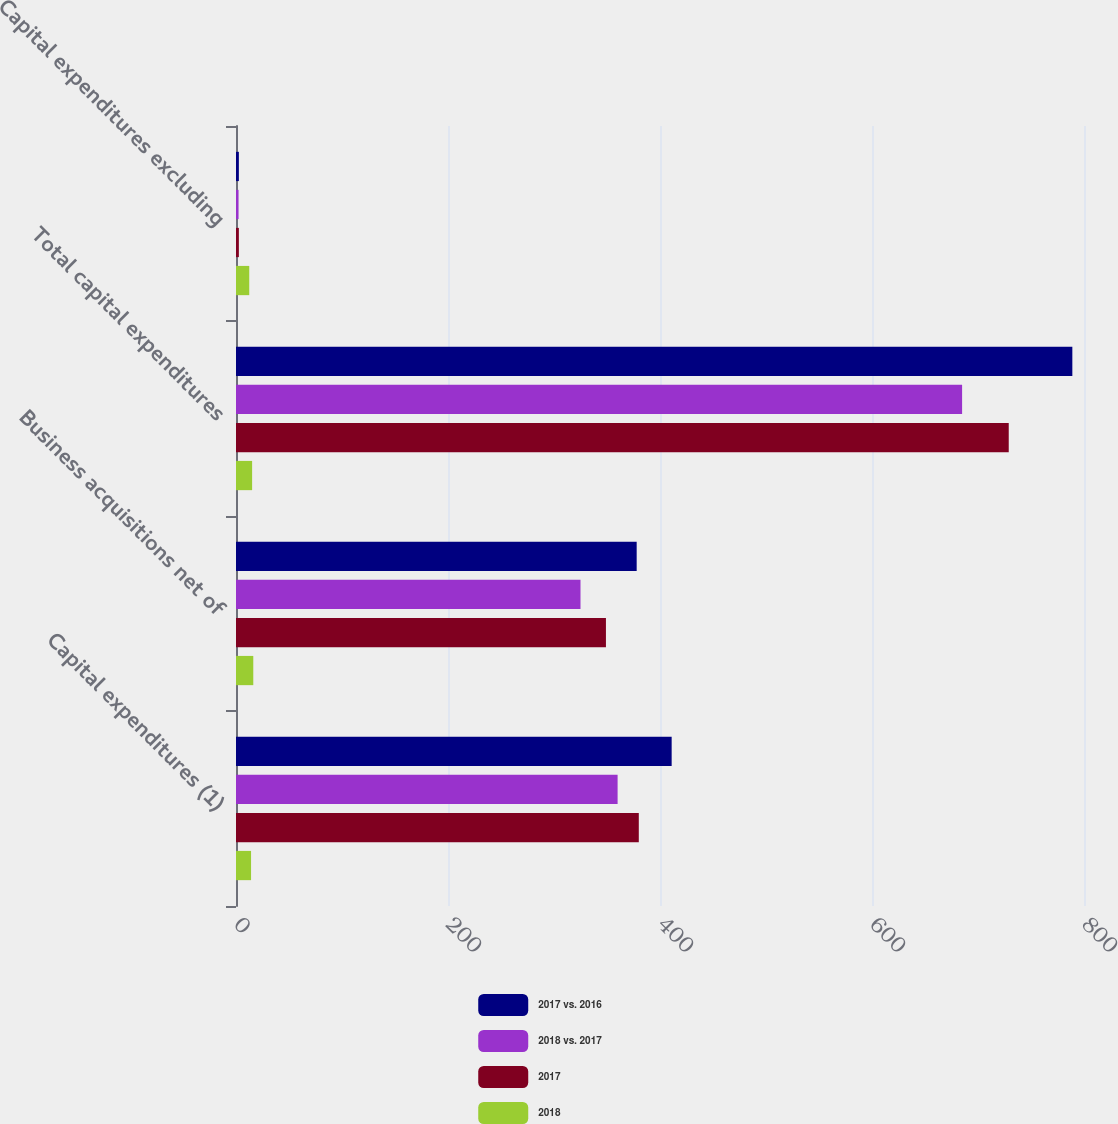Convert chart to OTSL. <chart><loc_0><loc_0><loc_500><loc_500><stacked_bar_chart><ecel><fcel>Capital expenditures (1)<fcel>Business acquisitions net of<fcel>Total capital expenditures<fcel>Capital expenditures excluding<nl><fcel>2017 vs. 2016<fcel>411<fcel>378<fcel>789<fcel>2.7<nl><fcel>2018 vs. 2017<fcel>360<fcel>325<fcel>685<fcel>2.4<nl><fcel>2017<fcel>380<fcel>349<fcel>729<fcel>2.7<nl><fcel>2018<fcel>14.2<fcel>16.3<fcel>15.2<fcel>12.5<nl></chart> 